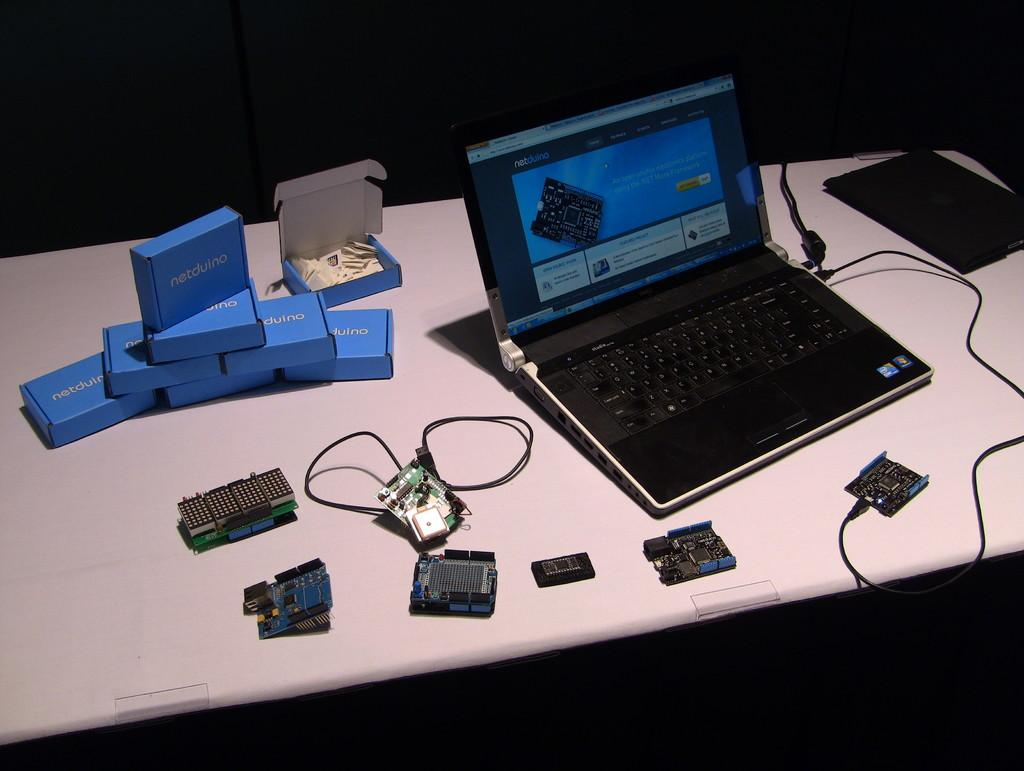<image>
Share a concise interpretation of the image provided. Some small boxes next to a laptop are labeled Netduino. 